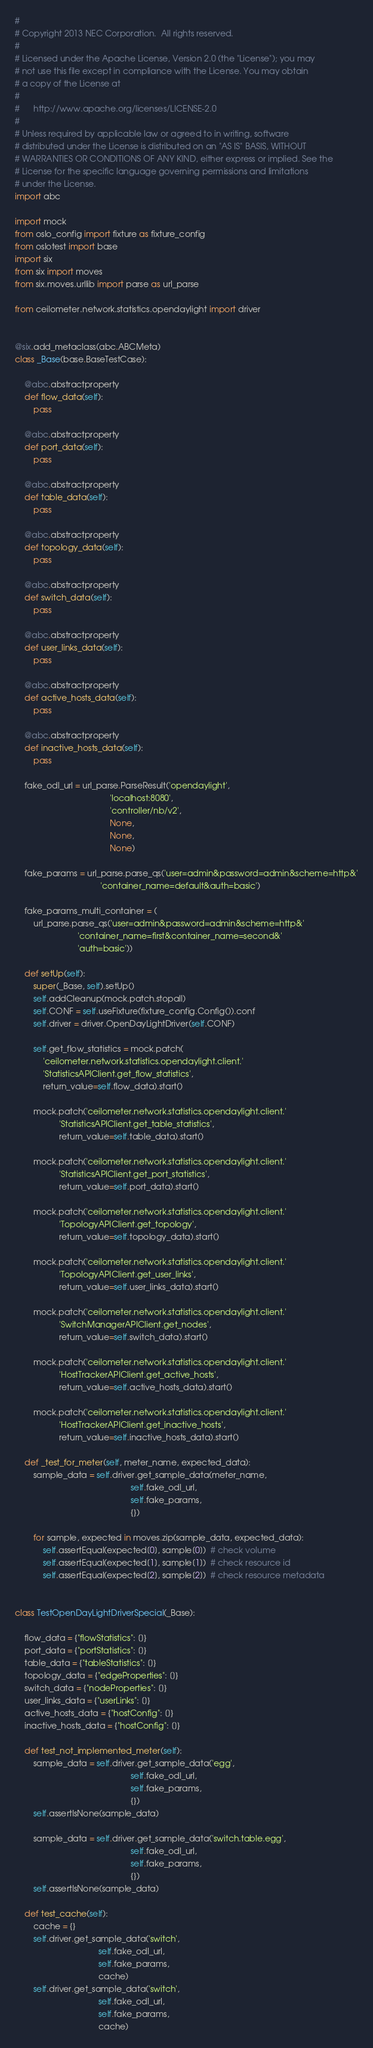Convert code to text. <code><loc_0><loc_0><loc_500><loc_500><_Python_>#
# Copyright 2013 NEC Corporation.  All rights reserved.
#
# Licensed under the Apache License, Version 2.0 (the "License"); you may
# not use this file except in compliance with the License. You may obtain
# a copy of the License at
#
#      http://www.apache.org/licenses/LICENSE-2.0
#
# Unless required by applicable law or agreed to in writing, software
# distributed under the License is distributed on an "AS IS" BASIS, WITHOUT
# WARRANTIES OR CONDITIONS OF ANY KIND, either express or implied. See the
# License for the specific language governing permissions and limitations
# under the License.
import abc

import mock
from oslo_config import fixture as fixture_config
from oslotest import base
import six
from six import moves
from six.moves.urllib import parse as url_parse

from ceilometer.network.statistics.opendaylight import driver


@six.add_metaclass(abc.ABCMeta)
class _Base(base.BaseTestCase):

    @abc.abstractproperty
    def flow_data(self):
        pass

    @abc.abstractproperty
    def port_data(self):
        pass

    @abc.abstractproperty
    def table_data(self):
        pass

    @abc.abstractproperty
    def topology_data(self):
        pass

    @abc.abstractproperty
    def switch_data(self):
        pass

    @abc.abstractproperty
    def user_links_data(self):
        pass

    @abc.abstractproperty
    def active_hosts_data(self):
        pass

    @abc.abstractproperty
    def inactive_hosts_data(self):
        pass

    fake_odl_url = url_parse.ParseResult('opendaylight',
                                         'localhost:8080',
                                         'controller/nb/v2',
                                         None,
                                         None,
                                         None)

    fake_params = url_parse.parse_qs('user=admin&password=admin&scheme=http&'
                                     'container_name=default&auth=basic')

    fake_params_multi_container = (
        url_parse.parse_qs('user=admin&password=admin&scheme=http&'
                           'container_name=first&container_name=second&'
                           'auth=basic'))

    def setUp(self):
        super(_Base, self).setUp()
        self.addCleanup(mock.patch.stopall)
        self.CONF = self.useFixture(fixture_config.Config()).conf
        self.driver = driver.OpenDayLightDriver(self.CONF)

        self.get_flow_statistics = mock.patch(
            'ceilometer.network.statistics.opendaylight.client.'
            'StatisticsAPIClient.get_flow_statistics',
            return_value=self.flow_data).start()

        mock.patch('ceilometer.network.statistics.opendaylight.client.'
                   'StatisticsAPIClient.get_table_statistics',
                   return_value=self.table_data).start()

        mock.patch('ceilometer.network.statistics.opendaylight.client.'
                   'StatisticsAPIClient.get_port_statistics',
                   return_value=self.port_data).start()

        mock.patch('ceilometer.network.statistics.opendaylight.client.'
                   'TopologyAPIClient.get_topology',
                   return_value=self.topology_data).start()

        mock.patch('ceilometer.network.statistics.opendaylight.client.'
                   'TopologyAPIClient.get_user_links',
                   return_value=self.user_links_data).start()

        mock.patch('ceilometer.network.statistics.opendaylight.client.'
                   'SwitchManagerAPIClient.get_nodes',
                   return_value=self.switch_data).start()

        mock.patch('ceilometer.network.statistics.opendaylight.client.'
                   'HostTrackerAPIClient.get_active_hosts',
                   return_value=self.active_hosts_data).start()

        mock.patch('ceilometer.network.statistics.opendaylight.client.'
                   'HostTrackerAPIClient.get_inactive_hosts',
                   return_value=self.inactive_hosts_data).start()

    def _test_for_meter(self, meter_name, expected_data):
        sample_data = self.driver.get_sample_data(meter_name,
                                                  self.fake_odl_url,
                                                  self.fake_params,
                                                  {})

        for sample, expected in moves.zip(sample_data, expected_data):
            self.assertEqual(expected[0], sample[0])  # check volume
            self.assertEqual(expected[1], sample[1])  # check resource id
            self.assertEqual(expected[2], sample[2])  # check resource metadata


class TestOpenDayLightDriverSpecial(_Base):

    flow_data = {"flowStatistics": []}
    port_data = {"portStatistics": []}
    table_data = {"tableStatistics": []}
    topology_data = {"edgeProperties": []}
    switch_data = {"nodeProperties": []}
    user_links_data = {"userLinks": []}
    active_hosts_data = {"hostConfig": []}
    inactive_hosts_data = {"hostConfig": []}

    def test_not_implemented_meter(self):
        sample_data = self.driver.get_sample_data('egg',
                                                  self.fake_odl_url,
                                                  self.fake_params,
                                                  {})
        self.assertIsNone(sample_data)

        sample_data = self.driver.get_sample_data('switch.table.egg',
                                                  self.fake_odl_url,
                                                  self.fake_params,
                                                  {})
        self.assertIsNone(sample_data)

    def test_cache(self):
        cache = {}
        self.driver.get_sample_data('switch',
                                    self.fake_odl_url,
                                    self.fake_params,
                                    cache)
        self.driver.get_sample_data('switch',
                                    self.fake_odl_url,
                                    self.fake_params,
                                    cache)</code> 